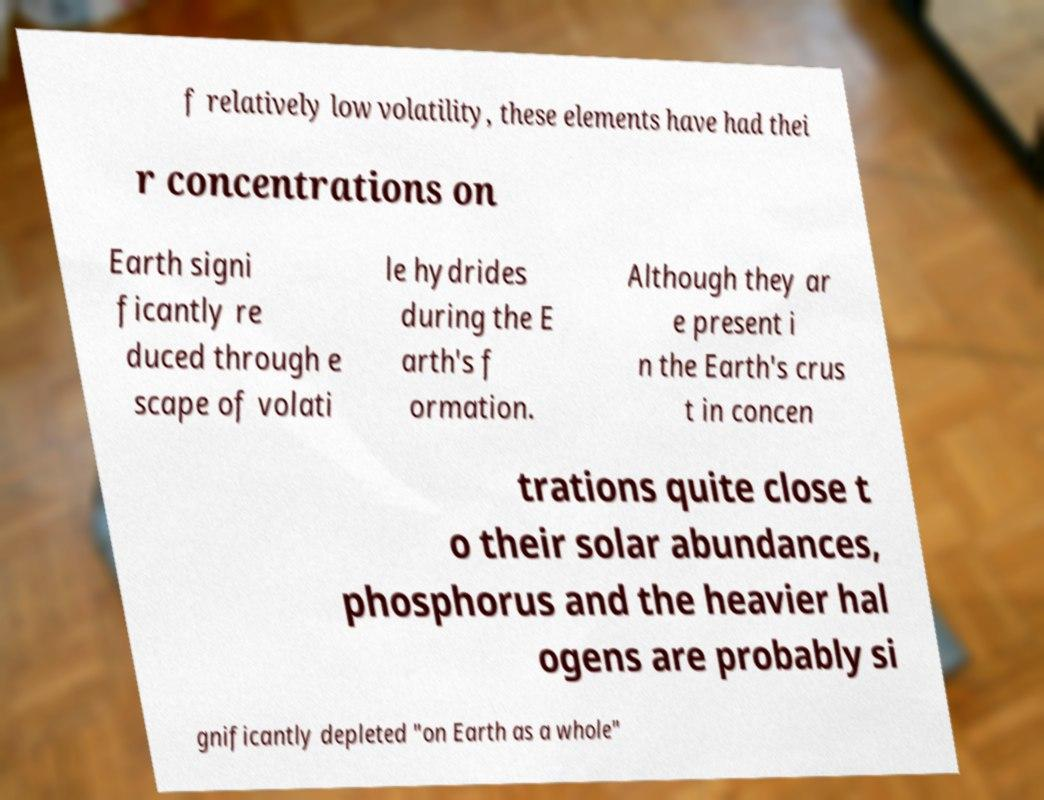I need the written content from this picture converted into text. Can you do that? f relatively low volatility, these elements have had thei r concentrations on Earth signi ficantly re duced through e scape of volati le hydrides during the E arth's f ormation. Although they ar e present i n the Earth's crus t in concen trations quite close t o their solar abundances, phosphorus and the heavier hal ogens are probably si gnificantly depleted "on Earth as a whole" 